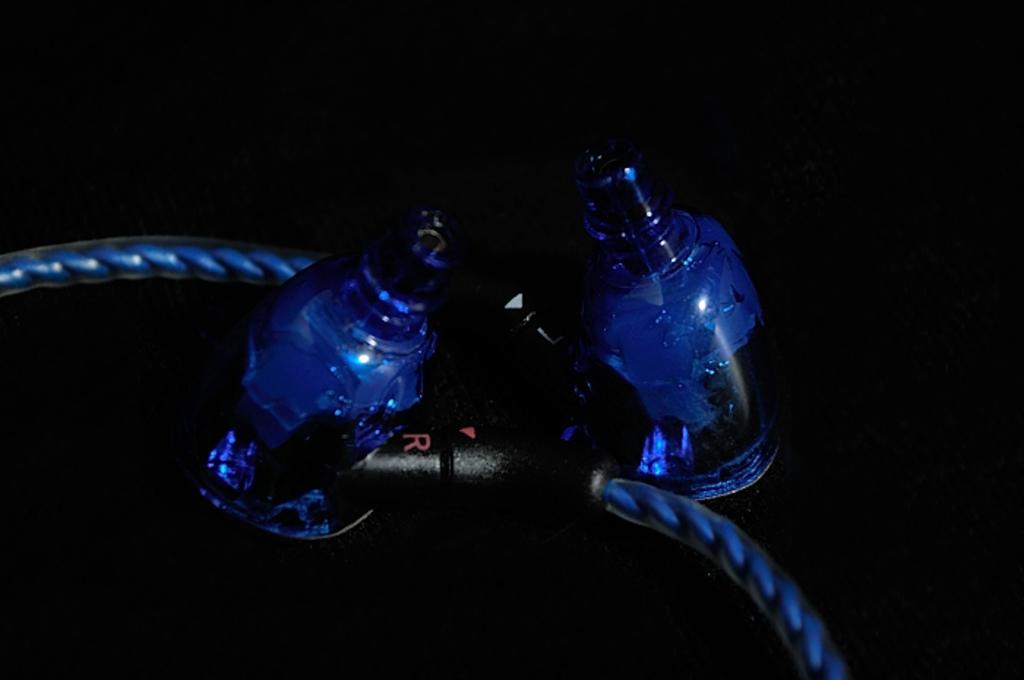What is the letter in red font?
Your answer should be very brief. R. 